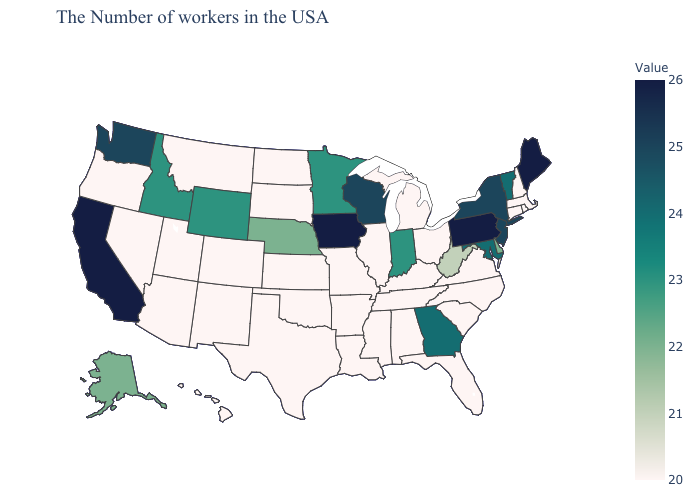Does Washington have a lower value than Virginia?
Answer briefly. No. Does Oregon have a higher value than Vermont?
Give a very brief answer. No. Is the legend a continuous bar?
Answer briefly. Yes. Does Alaska have the lowest value in the West?
Short answer required. No. 